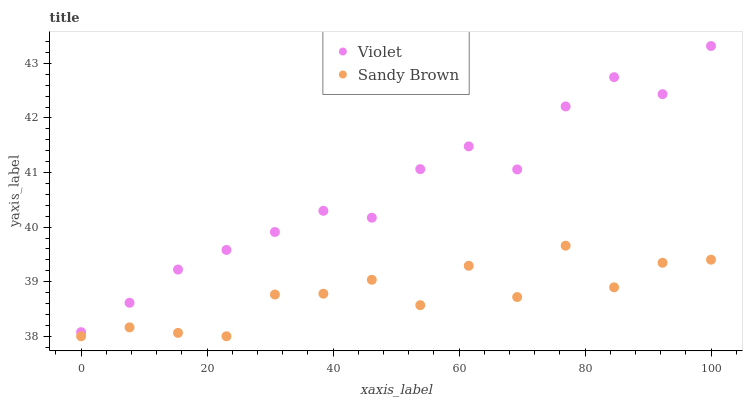Does Sandy Brown have the minimum area under the curve?
Answer yes or no. Yes. Does Violet have the maximum area under the curve?
Answer yes or no. Yes. Does Violet have the minimum area under the curve?
Answer yes or no. No. Is Violet the smoothest?
Answer yes or no. Yes. Is Sandy Brown the roughest?
Answer yes or no. Yes. Is Violet the roughest?
Answer yes or no. No. Does Sandy Brown have the lowest value?
Answer yes or no. Yes. Does Violet have the lowest value?
Answer yes or no. No. Does Violet have the highest value?
Answer yes or no. Yes. Is Sandy Brown less than Violet?
Answer yes or no. Yes. Is Violet greater than Sandy Brown?
Answer yes or no. Yes. Does Sandy Brown intersect Violet?
Answer yes or no. No. 